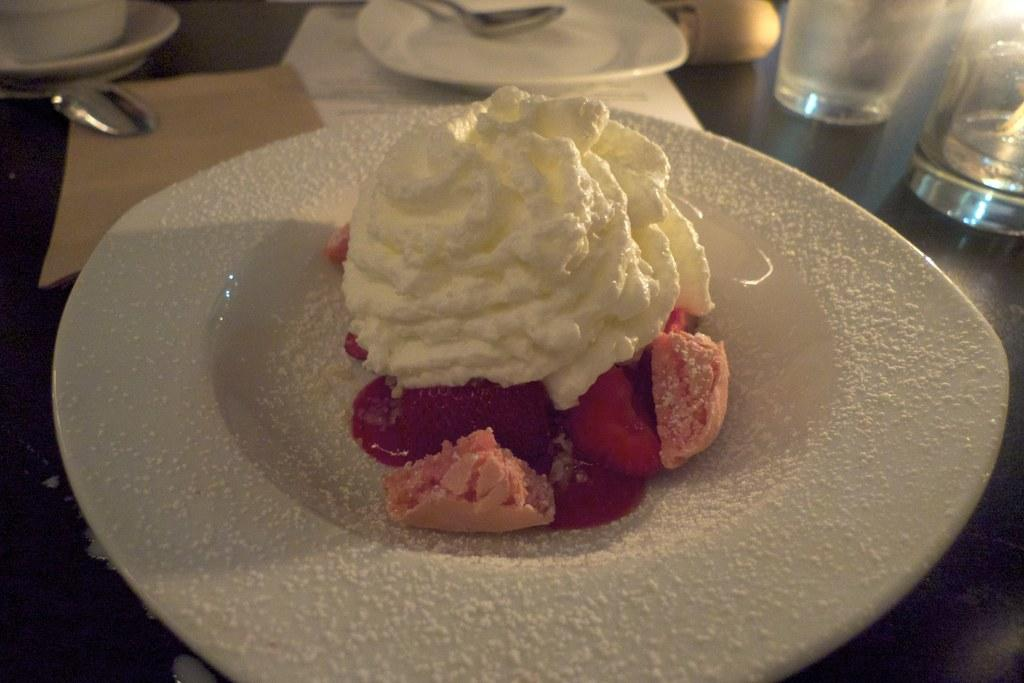What type of dessert is present in the image? There is ice cream in the image. How is the ice cream presented? The ice cream is in a plate. What else can be seen on the table in the image? There are glasses visible in the image, as well as other things. What type of prison can be seen in the background of the image? There is no prison present in the image; it only features ice cream in a plate, glasses, and other unspecified items on the table. 